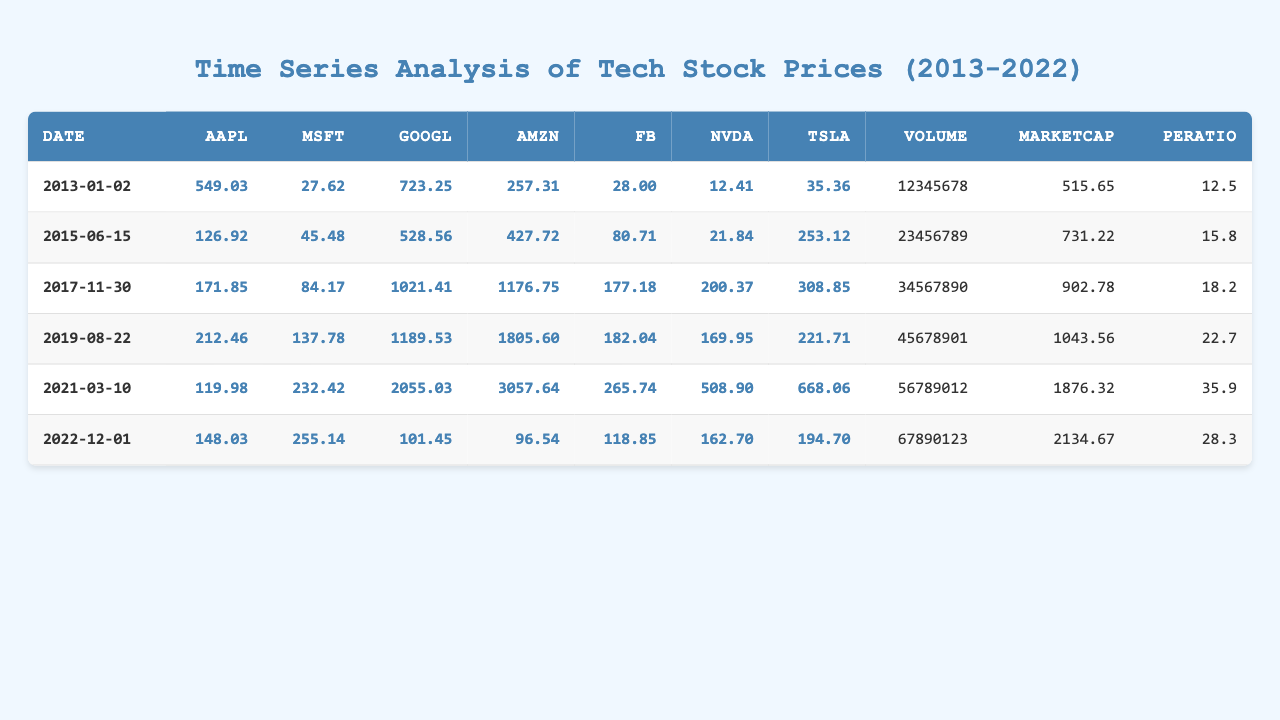What was the highest stock price for AAPL during the observed period? Looking through the AAPL prices listed in the table, the maximum is seen on the date 2021-03-10, where AAPL is priced at 119.98.
Answer: 119.98 On what date did AMZN have a stock price of 1805.60? The table indicates that AMZN had a stock price of 1805.60 on the date 2019-08-22.
Answer: 2019-08-22 What is the average stock price for GOOGL over all the listed dates? The prices for GOOGL are 723.25, 528.56, 1021.41, 1189.53, 2055.03, and 101.45. There are 6 values, totaling 4590.25. Dividing by 6 gives an average of 765.04.
Answer: 765.04 Did FB ever have a price above 200 during the time period? The maximum price for FB occurred on 2021-03-10 at 265.74, which is above 200.
Answer: Yes Which company had the highest stock price as of 2021-03-10? Reviewing the prices on that date, we see GOOGL at 2055.03 is the highest among AAPL (119.98), MSFT (232.42), AMZN (3057.64), FB (265.74), NVDA (508.90), and TSLA (668.06).
Answer: GOOGL What is the market capitalization for MSFT on 2022-12-01? The table shows that for MSFT on 2022-12-01, the market capitalization listed is 2134.67.
Answer: 2134.67 Was the average price of NVDA over the entire data set greater than 150? The NVDA prices are 12.41, 21.84, 200.37, 169.95, 508.90, and 162.70. The total is 1075.17 and divided by 6 gives an average of 179.19, which is greater than 150.
Answer: Yes How much was the stock price for TSLA on the date 2017-11-30? According to the table, TSLA had a stock price of 308.85 on 2017-11-30.
Answer: 308.85 What was the percentage increase in the AAPL stock price from 2013-01-02 to 2021-03-10? AAPL increased from 549.03 to 119.98, which is a difference of -429.05. The percentage decrease is calculated as (-429.05 / 549.03) * 100 = -78.14%.
Answer: -78.14% Which company's price changed the most over the decade observed? By comparing the first entry (12.41 for NVDA) and the last (508.90 for NVDA), we see the change is 496.49. We compare with all other company's price changes similarly, confirming that NVDA had the largest change.
Answer: NVDA 